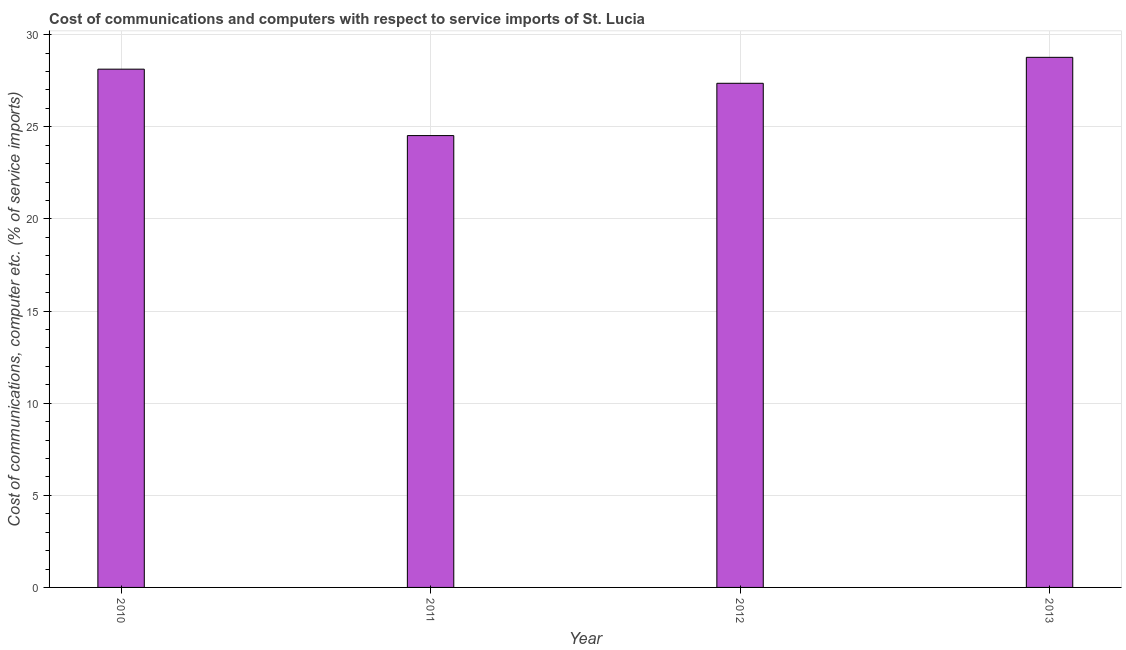Does the graph contain any zero values?
Your answer should be compact. No. What is the title of the graph?
Ensure brevity in your answer.  Cost of communications and computers with respect to service imports of St. Lucia. What is the label or title of the Y-axis?
Your answer should be very brief. Cost of communications, computer etc. (% of service imports). What is the cost of communications and computer in 2011?
Keep it short and to the point. 24.52. Across all years, what is the maximum cost of communications and computer?
Offer a very short reply. 28.77. Across all years, what is the minimum cost of communications and computer?
Offer a very short reply. 24.52. In which year was the cost of communications and computer maximum?
Offer a very short reply. 2013. What is the sum of the cost of communications and computer?
Provide a short and direct response. 108.78. What is the difference between the cost of communications and computer in 2011 and 2013?
Keep it short and to the point. -4.25. What is the average cost of communications and computer per year?
Provide a short and direct response. 27.2. What is the median cost of communications and computer?
Your response must be concise. 27.74. What is the ratio of the cost of communications and computer in 2012 to that in 2013?
Make the answer very short. 0.95. Is the cost of communications and computer in 2010 less than that in 2012?
Ensure brevity in your answer.  No. Is the difference between the cost of communications and computer in 2010 and 2011 greater than the difference between any two years?
Your response must be concise. No. What is the difference between the highest and the second highest cost of communications and computer?
Keep it short and to the point. 0.64. What is the difference between the highest and the lowest cost of communications and computer?
Offer a very short reply. 4.25. In how many years, is the cost of communications and computer greater than the average cost of communications and computer taken over all years?
Your response must be concise. 3. How many bars are there?
Keep it short and to the point. 4. How many years are there in the graph?
Provide a short and direct response. 4. What is the Cost of communications, computer etc. (% of service imports) of 2010?
Provide a short and direct response. 28.13. What is the Cost of communications, computer etc. (% of service imports) of 2011?
Keep it short and to the point. 24.52. What is the Cost of communications, computer etc. (% of service imports) in 2012?
Ensure brevity in your answer.  27.36. What is the Cost of communications, computer etc. (% of service imports) in 2013?
Keep it short and to the point. 28.77. What is the difference between the Cost of communications, computer etc. (% of service imports) in 2010 and 2011?
Provide a short and direct response. 3.6. What is the difference between the Cost of communications, computer etc. (% of service imports) in 2010 and 2012?
Your answer should be compact. 0.77. What is the difference between the Cost of communications, computer etc. (% of service imports) in 2010 and 2013?
Make the answer very short. -0.64. What is the difference between the Cost of communications, computer etc. (% of service imports) in 2011 and 2012?
Give a very brief answer. -2.84. What is the difference between the Cost of communications, computer etc. (% of service imports) in 2011 and 2013?
Provide a succinct answer. -4.25. What is the difference between the Cost of communications, computer etc. (% of service imports) in 2012 and 2013?
Your answer should be compact. -1.41. What is the ratio of the Cost of communications, computer etc. (% of service imports) in 2010 to that in 2011?
Keep it short and to the point. 1.15. What is the ratio of the Cost of communications, computer etc. (% of service imports) in 2010 to that in 2012?
Your response must be concise. 1.03. What is the ratio of the Cost of communications, computer etc. (% of service imports) in 2011 to that in 2012?
Provide a short and direct response. 0.9. What is the ratio of the Cost of communications, computer etc. (% of service imports) in 2011 to that in 2013?
Offer a very short reply. 0.85. What is the ratio of the Cost of communications, computer etc. (% of service imports) in 2012 to that in 2013?
Offer a terse response. 0.95. 